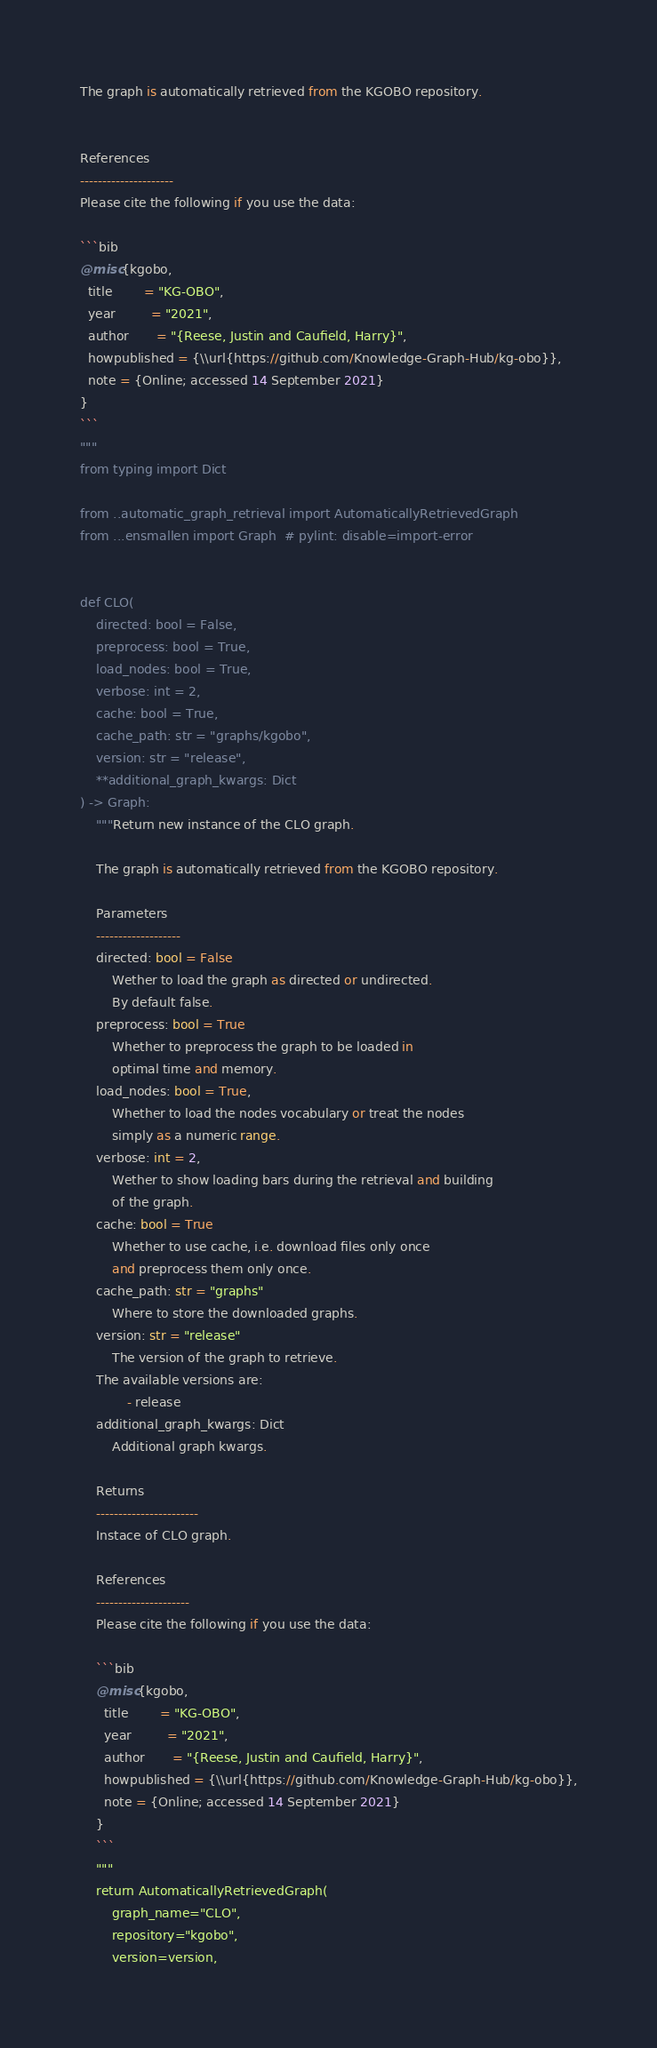<code> <loc_0><loc_0><loc_500><loc_500><_Python_>
The graph is automatically retrieved from the KGOBO repository. 


References
---------------------
Please cite the following if you use the data:

```bib
@misc{kgobo,
  title        = "KG-OBO",
  year         = "2021",
  author       = "{Reese, Justin and Caufield, Harry}",
  howpublished = {\\url{https://github.com/Knowledge-Graph-Hub/kg-obo}},
  note = {Online; accessed 14 September 2021}
}
```
"""
from typing import Dict

from ..automatic_graph_retrieval import AutomaticallyRetrievedGraph
from ...ensmallen import Graph  # pylint: disable=import-error


def CLO(
    directed: bool = False,
    preprocess: bool = True,
    load_nodes: bool = True,
    verbose: int = 2,
    cache: bool = True,
    cache_path: str = "graphs/kgobo",
    version: str = "release",
    **additional_graph_kwargs: Dict
) -> Graph:
    """Return new instance of the CLO graph.

    The graph is automatically retrieved from the KGOBO repository.	

    Parameters
    -------------------
    directed: bool = False
        Wether to load the graph as directed or undirected.
        By default false.
    preprocess: bool = True
        Whether to preprocess the graph to be loaded in 
        optimal time and memory.
    load_nodes: bool = True,
        Whether to load the nodes vocabulary or treat the nodes
        simply as a numeric range.
    verbose: int = 2,
        Wether to show loading bars during the retrieval and building
        of the graph.
    cache: bool = True
        Whether to use cache, i.e. download files only once
        and preprocess them only once.
    cache_path: str = "graphs"
        Where to store the downloaded graphs.
    version: str = "release"
        The version of the graph to retrieve.		
	The available versions are:
			- release
    additional_graph_kwargs: Dict
        Additional graph kwargs.

    Returns
    -----------------------
    Instace of CLO graph.

	References
	---------------------
	Please cite the following if you use the data:
	
	```bib
	@misc{kgobo,
	  title        = "KG-OBO",
	  year         = "2021",
	  author       = "{Reese, Justin and Caufield, Harry}",
	  howpublished = {\\url{https://github.com/Knowledge-Graph-Hub/kg-obo}},
	  note = {Online; accessed 14 September 2021}
	}
	```
    """
    return AutomaticallyRetrievedGraph(
        graph_name="CLO",
        repository="kgobo",
        version=version,</code> 